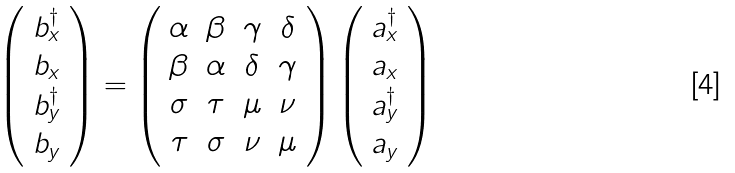<formula> <loc_0><loc_0><loc_500><loc_500>\left ( \begin{array} { c } b ^ { \dagger } _ { x } \\ b _ { x } \\ b ^ { \dagger } _ { y } \\ b _ { y } \end{array} \right ) = \left ( \begin{array} { c c c c } \alpha & \beta & \gamma & \delta \\ \beta & \alpha & \delta & \gamma \\ \sigma & \tau & \mu & \nu \\ \tau & \sigma & \nu & \mu \end{array} \right ) \left ( \begin{array} { c } a ^ { \dagger } _ { x } \\ a _ { x } \\ a ^ { \dagger } _ { y } \\ a _ { y } \end{array} \right )</formula> 